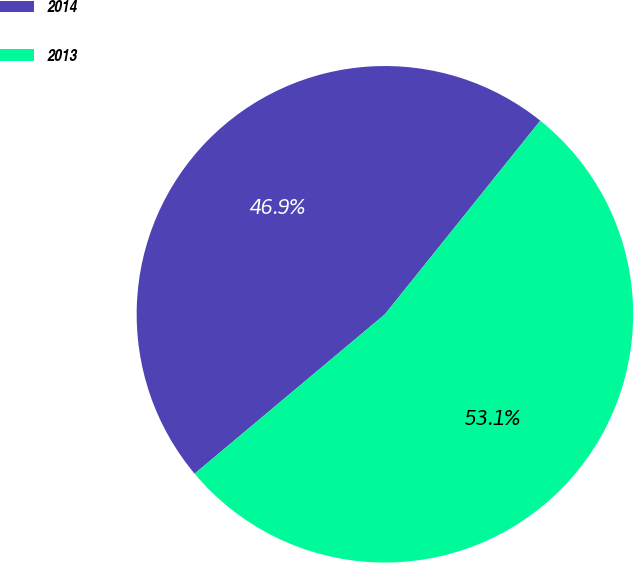Convert chart. <chart><loc_0><loc_0><loc_500><loc_500><pie_chart><fcel>2014<fcel>2013<nl><fcel>46.86%<fcel>53.14%<nl></chart> 